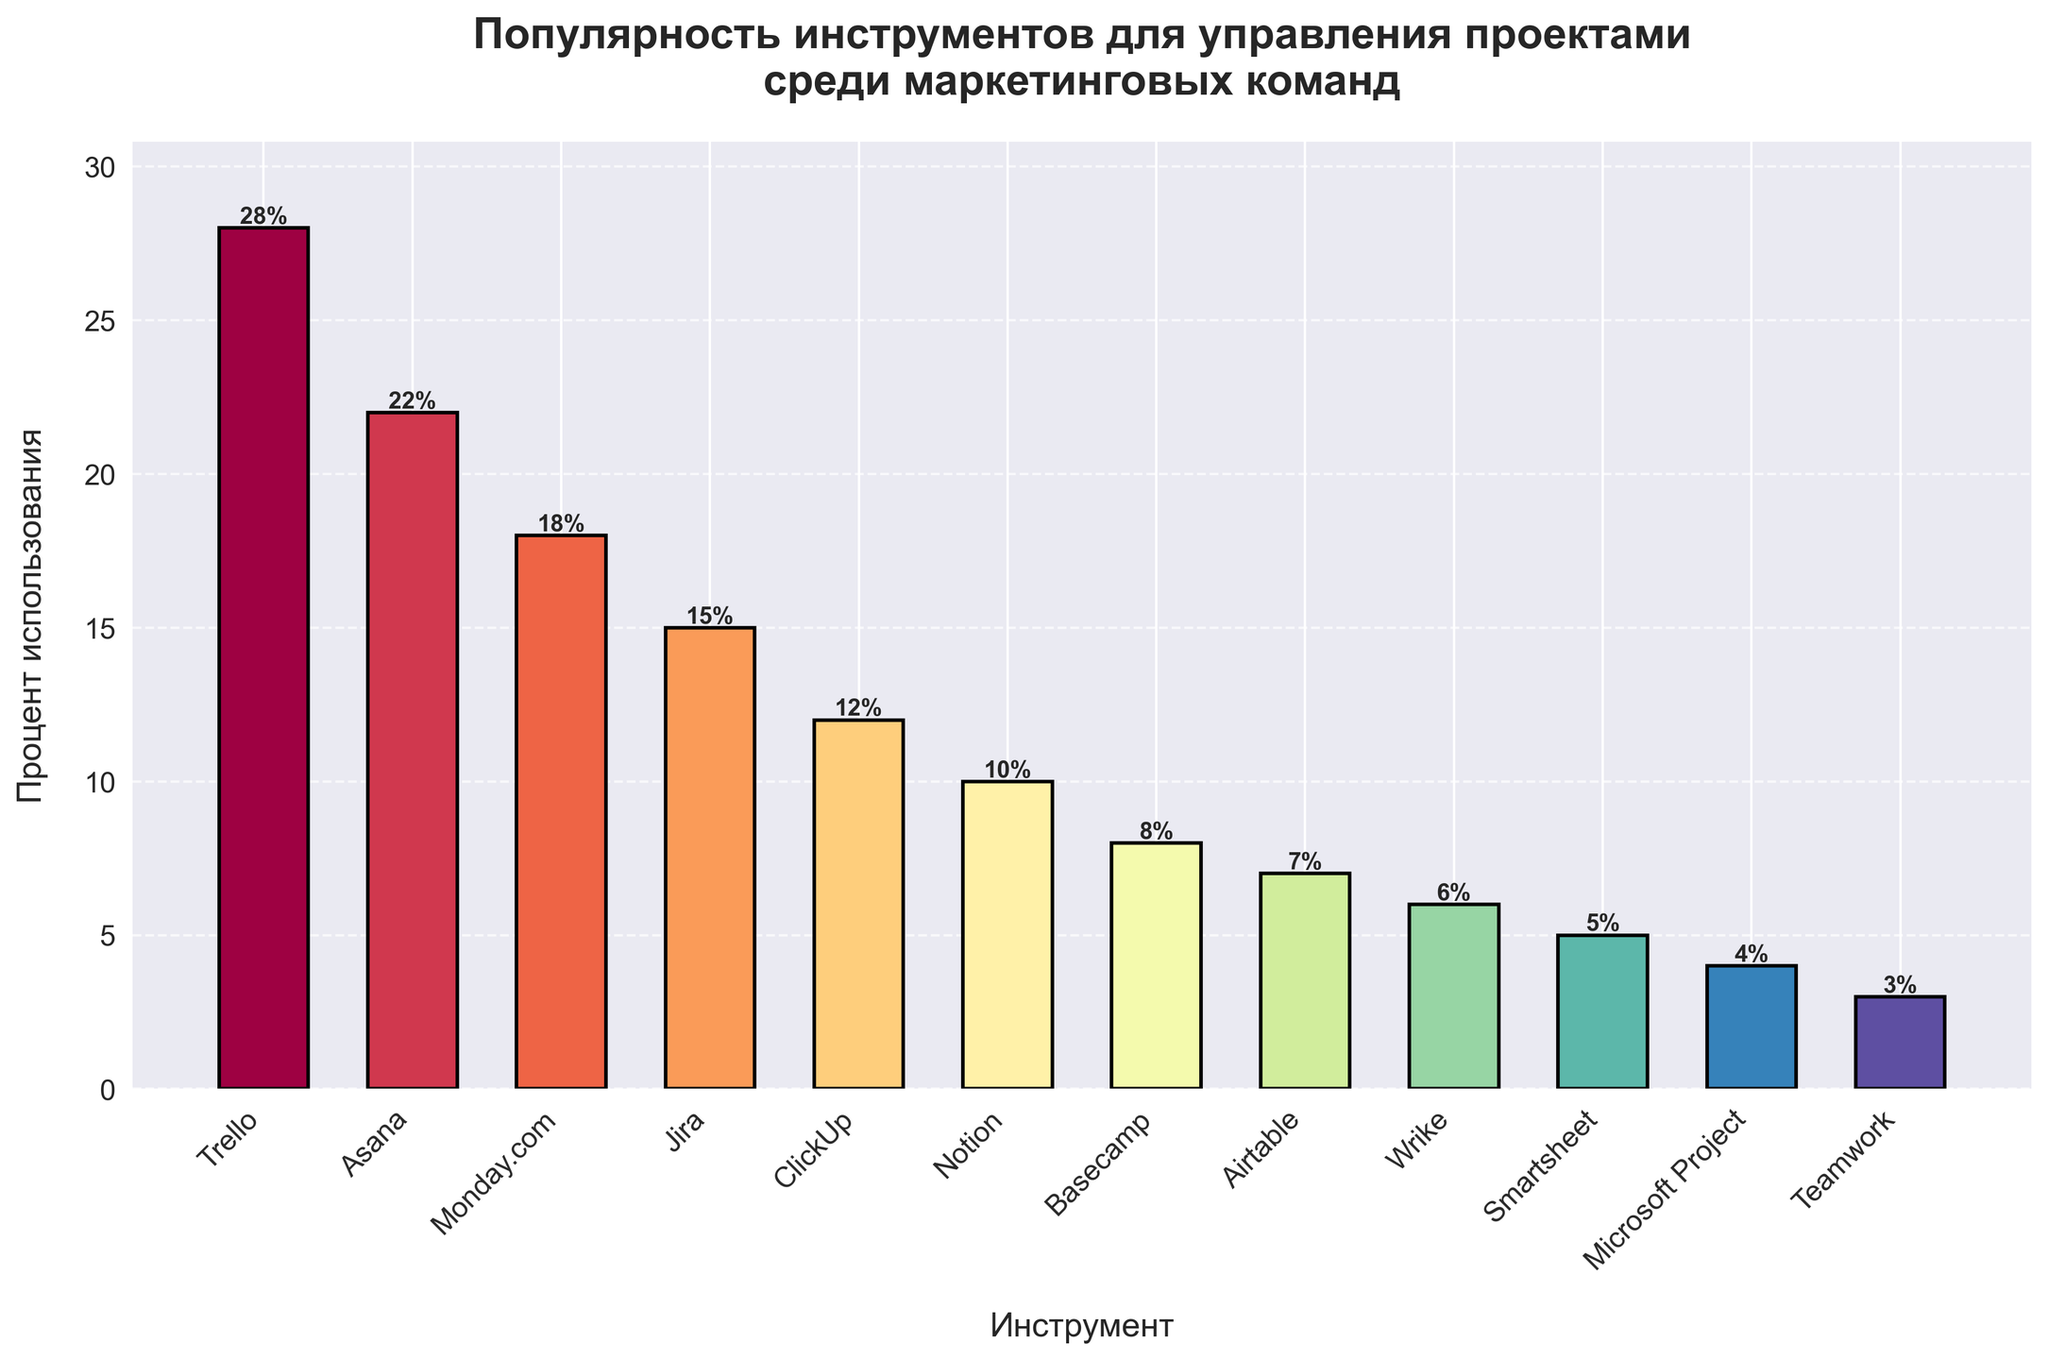какой инструмент является наиболее популярным среди маркетинговых команд? Самый высокий бар на графике представляет собой инструмент Trello, с 28% использования. Значит, Trello является самым популярным.
Answer: Trello какой инструмент менее популярен: Asana или Monday.com? На графике видно, что бар Asana выше, чем бар Monday.com. Asana имеет 22% использования, тогда как Monday.com имеет 18%. Следовательно, Monday.com менее популярен.
Answer: Monday.com как много процентов использования приходится на первые два самых популярных инструмента? Самые популярные инструменты - это Trello (28%) и Asana (22%). Складывая их проценты, получаем 28 + 22 = 50%.
Answer: 50% на сколько больше процент использования у Trello по сравнению с Jira? У Trello 28% использования, а у Jira 15%. Разница составляет 28 - 15 = 13%.
Answer: 13% какого цвета бар у инструмента с наименьшим процентом использования? С самым низким процентом использования (3%) выступает инструмент Teamwork. На графике его бар окрашен в конкретный цвет (например, темно-фиолетовый).
Answer: темно-фиолетовый какой средний процент использования у инструментов Asana, Monday.com и ClickUp? Процент использования Asana - 22%, Monday.com - 18%, ClickUp - 12%. Средний процент можно найти, сложив эти значения и разделив на количество инструментов: (22 + 18 + 12) / 3 = 52 / 3 ≈ 17.33%.
Answer: 17.33% какой инструмент находится между Monday.com и Notion по проценту использования? На графике видно, что Jira с 15% использования находится между Monday.com (18%) и Notion (10%) в порядке популярности.
Answer: Jira есть ли разница в процентах использования между Basecamp и Airtable? Если да, то какая? Процент использования Basecamp составляет 8%, а Airtable - 7%. Разница составляет 8 - 7 = 1%.
Answer: 1% какие три инструмента имеют менее 10% использования? На графике видно, что Notion (10%), Basecamp (8%), Airtable (7%), Wrike (6%), Smartsheet (5%), Microsoft Project (4%) и Teamwork (3%) имеют менее 10% использования. Но среди них ясно, что три инструмента - это Basecamp, Airtable и Wrike.
Answer: Basecamp, Airtable, Wrike как называется инструмент, чей бар окрашен в красный цвет? Красный цвет на графике относится к инструменту, который выделяется среди других. Это цветовой акцент, используемый для наглядности. В данном случае это инструмент Notion.
Answer: Notion 